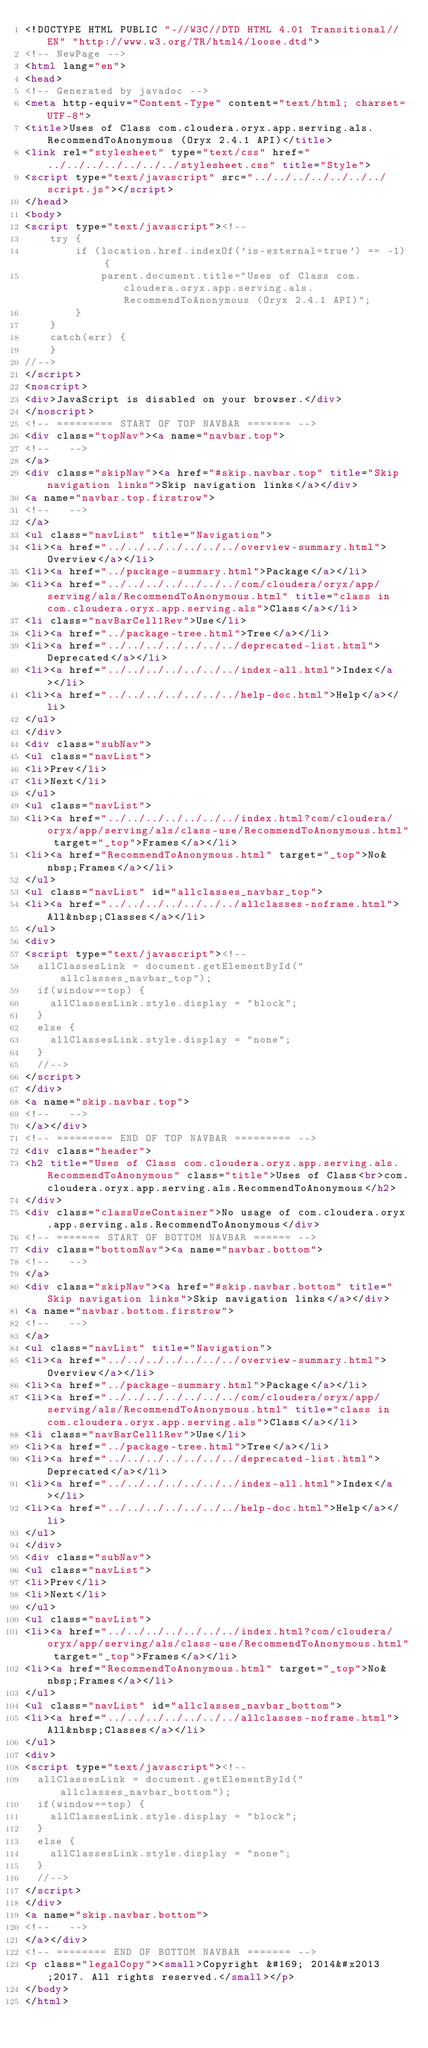<code> <loc_0><loc_0><loc_500><loc_500><_HTML_><!DOCTYPE HTML PUBLIC "-//W3C//DTD HTML 4.01 Transitional//EN" "http://www.w3.org/TR/html4/loose.dtd">
<!-- NewPage -->
<html lang="en">
<head>
<!-- Generated by javadoc -->
<meta http-equiv="Content-Type" content="text/html; charset=UTF-8">
<title>Uses of Class com.cloudera.oryx.app.serving.als.RecommendToAnonymous (Oryx 2.4.1 API)</title>
<link rel="stylesheet" type="text/css" href="../../../../../../../stylesheet.css" title="Style">
<script type="text/javascript" src="../../../../../../../script.js"></script>
</head>
<body>
<script type="text/javascript"><!--
    try {
        if (location.href.indexOf('is-external=true') == -1) {
            parent.document.title="Uses of Class com.cloudera.oryx.app.serving.als.RecommendToAnonymous (Oryx 2.4.1 API)";
        }
    }
    catch(err) {
    }
//-->
</script>
<noscript>
<div>JavaScript is disabled on your browser.</div>
</noscript>
<!-- ========= START OF TOP NAVBAR ======= -->
<div class="topNav"><a name="navbar.top">
<!--   -->
</a>
<div class="skipNav"><a href="#skip.navbar.top" title="Skip navigation links">Skip navigation links</a></div>
<a name="navbar.top.firstrow">
<!--   -->
</a>
<ul class="navList" title="Navigation">
<li><a href="../../../../../../../overview-summary.html">Overview</a></li>
<li><a href="../package-summary.html">Package</a></li>
<li><a href="../../../../../../../com/cloudera/oryx/app/serving/als/RecommendToAnonymous.html" title="class in com.cloudera.oryx.app.serving.als">Class</a></li>
<li class="navBarCell1Rev">Use</li>
<li><a href="../package-tree.html">Tree</a></li>
<li><a href="../../../../../../../deprecated-list.html">Deprecated</a></li>
<li><a href="../../../../../../../index-all.html">Index</a></li>
<li><a href="../../../../../../../help-doc.html">Help</a></li>
</ul>
</div>
<div class="subNav">
<ul class="navList">
<li>Prev</li>
<li>Next</li>
</ul>
<ul class="navList">
<li><a href="../../../../../../../index.html?com/cloudera/oryx/app/serving/als/class-use/RecommendToAnonymous.html" target="_top">Frames</a></li>
<li><a href="RecommendToAnonymous.html" target="_top">No&nbsp;Frames</a></li>
</ul>
<ul class="navList" id="allclasses_navbar_top">
<li><a href="../../../../../../../allclasses-noframe.html">All&nbsp;Classes</a></li>
</ul>
<div>
<script type="text/javascript"><!--
  allClassesLink = document.getElementById("allclasses_navbar_top");
  if(window==top) {
    allClassesLink.style.display = "block";
  }
  else {
    allClassesLink.style.display = "none";
  }
  //-->
</script>
</div>
<a name="skip.navbar.top">
<!--   -->
</a></div>
<!-- ========= END OF TOP NAVBAR ========= -->
<div class="header">
<h2 title="Uses of Class com.cloudera.oryx.app.serving.als.RecommendToAnonymous" class="title">Uses of Class<br>com.cloudera.oryx.app.serving.als.RecommendToAnonymous</h2>
</div>
<div class="classUseContainer">No usage of com.cloudera.oryx.app.serving.als.RecommendToAnonymous</div>
<!-- ======= START OF BOTTOM NAVBAR ====== -->
<div class="bottomNav"><a name="navbar.bottom">
<!--   -->
</a>
<div class="skipNav"><a href="#skip.navbar.bottom" title="Skip navigation links">Skip navigation links</a></div>
<a name="navbar.bottom.firstrow">
<!--   -->
</a>
<ul class="navList" title="Navigation">
<li><a href="../../../../../../../overview-summary.html">Overview</a></li>
<li><a href="../package-summary.html">Package</a></li>
<li><a href="../../../../../../../com/cloudera/oryx/app/serving/als/RecommendToAnonymous.html" title="class in com.cloudera.oryx.app.serving.als">Class</a></li>
<li class="navBarCell1Rev">Use</li>
<li><a href="../package-tree.html">Tree</a></li>
<li><a href="../../../../../../../deprecated-list.html">Deprecated</a></li>
<li><a href="../../../../../../../index-all.html">Index</a></li>
<li><a href="../../../../../../../help-doc.html">Help</a></li>
</ul>
</div>
<div class="subNav">
<ul class="navList">
<li>Prev</li>
<li>Next</li>
</ul>
<ul class="navList">
<li><a href="../../../../../../../index.html?com/cloudera/oryx/app/serving/als/class-use/RecommendToAnonymous.html" target="_top">Frames</a></li>
<li><a href="RecommendToAnonymous.html" target="_top">No&nbsp;Frames</a></li>
</ul>
<ul class="navList" id="allclasses_navbar_bottom">
<li><a href="../../../../../../../allclasses-noframe.html">All&nbsp;Classes</a></li>
</ul>
<div>
<script type="text/javascript"><!--
  allClassesLink = document.getElementById("allclasses_navbar_bottom");
  if(window==top) {
    allClassesLink.style.display = "block";
  }
  else {
    allClassesLink.style.display = "none";
  }
  //-->
</script>
</div>
<a name="skip.navbar.bottom">
<!--   -->
</a></div>
<!-- ======== END OF BOTTOM NAVBAR ======= -->
<p class="legalCopy"><small>Copyright &#169; 2014&#x2013;2017. All rights reserved.</small></p>
</body>
</html>
</code> 